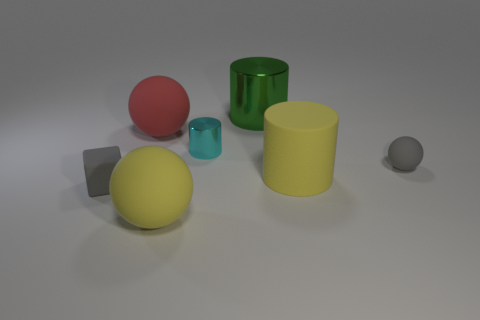There is a small thing that is the same color as the tiny ball; what material is it?
Offer a terse response. Rubber. There is a big yellow matte thing that is on the left side of the large metal thing; what shape is it?
Keep it short and to the point. Sphere. How many matte balls are there?
Make the answer very short. 3. What is the color of the cylinder that is the same material as the small cyan object?
Give a very brief answer. Green. What number of big objects are red objects or green shiny cylinders?
Your answer should be compact. 2. There is a small cyan thing; what number of large yellow rubber balls are behind it?
Make the answer very short. 0. There is a tiny thing that is the same shape as the big red thing; what is its color?
Offer a terse response. Gray. What number of rubber things are cyan objects or big cyan spheres?
Your answer should be very brief. 0. There is a gray matte object left of the tiny rubber thing right of the tiny gray cube; is there a small thing that is to the right of it?
Keep it short and to the point. Yes. What color is the small cube?
Provide a short and direct response. Gray. 